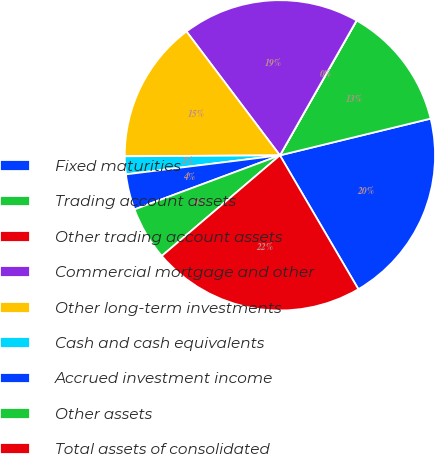Convert chart to OTSL. <chart><loc_0><loc_0><loc_500><loc_500><pie_chart><fcel>Fixed maturities<fcel>Trading account assets<fcel>Other trading account assets<fcel>Commercial mortgage and other<fcel>Other long-term investments<fcel>Cash and cash equivalents<fcel>Accrued investment income<fcel>Other assets<fcel>Total assets of consolidated<nl><fcel>20.36%<fcel>12.96%<fcel>0.01%<fcel>18.51%<fcel>14.81%<fcel>1.86%<fcel>3.71%<fcel>5.56%<fcel>22.21%<nl></chart> 